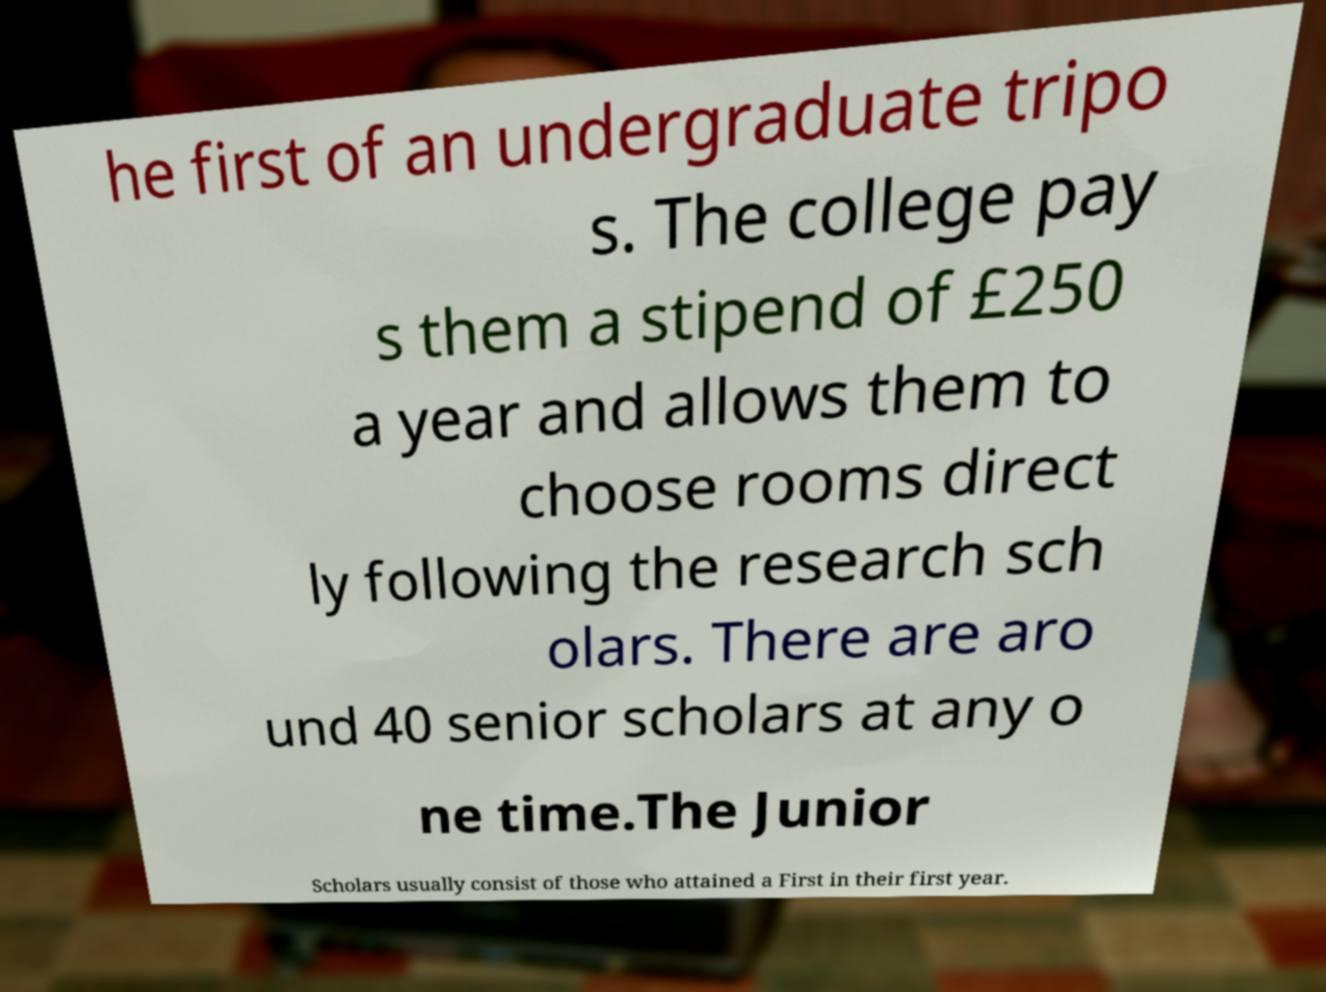I need the written content from this picture converted into text. Can you do that? he first of an undergraduate tripo s. The college pay s them a stipend of £250 a year and allows them to choose rooms direct ly following the research sch olars. There are aro und 40 senior scholars at any o ne time.The Junior Scholars usually consist of those who attained a First in their first year. 